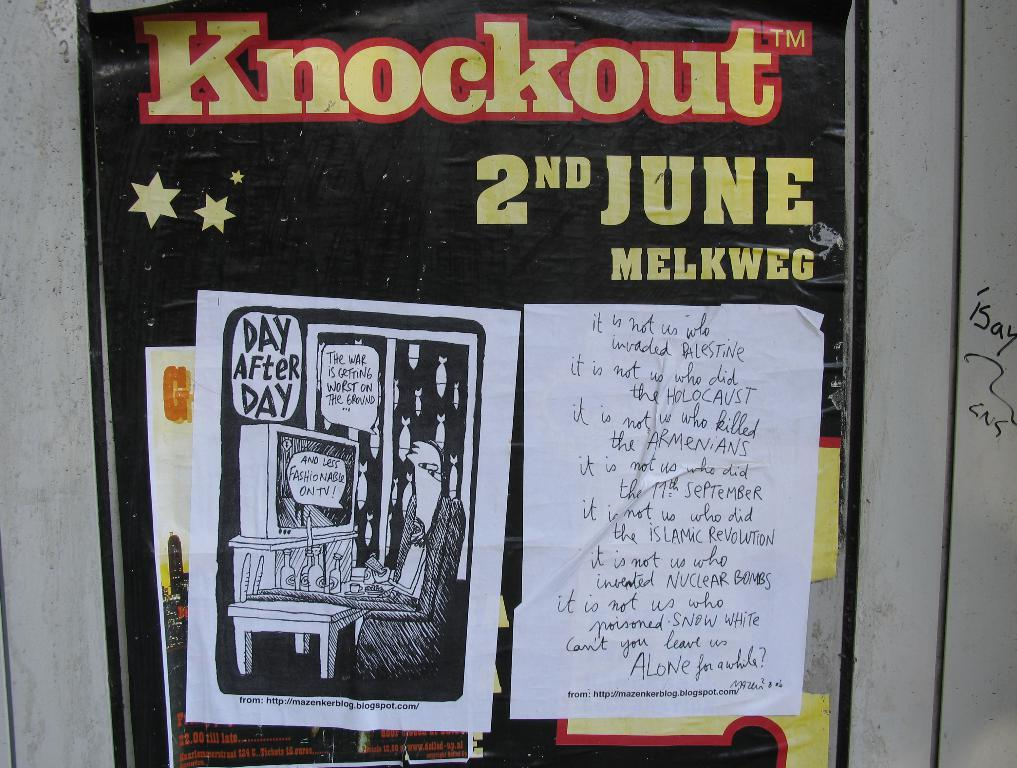Provide a one-sentence caption for the provided image. Posted on a wall a political cartoon and message about war are asking to be left a lone. 